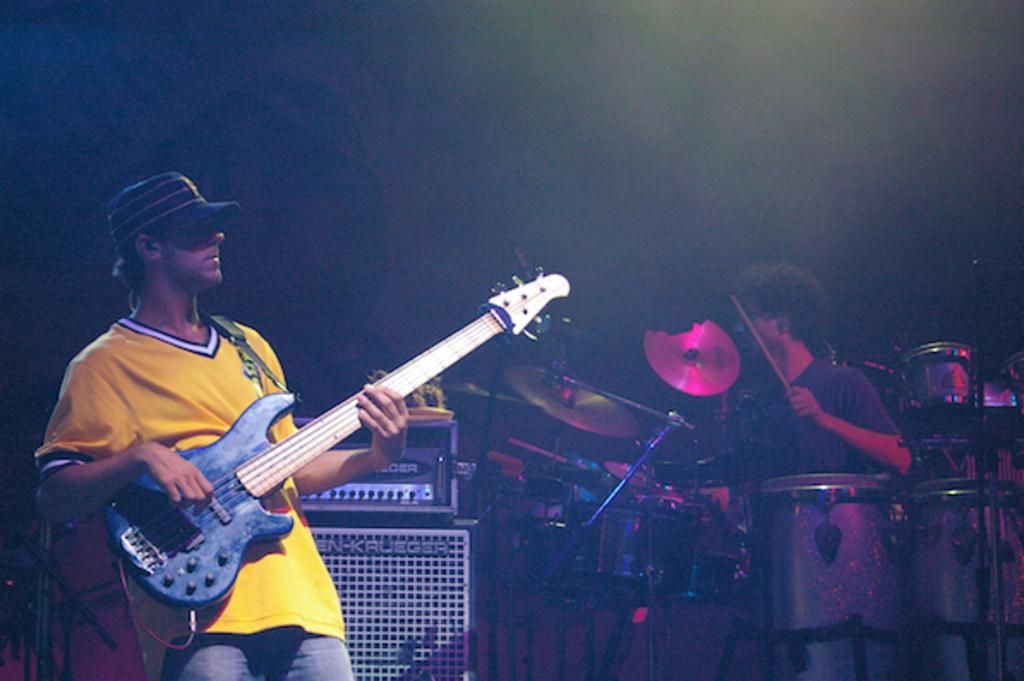What is the man on the left side of the image holding? The man on the left side of the image is holding a guitar. What is the man on the right side of the image holding? The man on the right side of the image is holding sticks. What instrument is associated with the sticks that the man is holding? The sticks are associated with drums, which are in front of the man holding them. What type of vessel is being used to transport steam in the image? There is no vessel or steam present in the image. How is the whip being used in the image? There is no whip present in the image. 